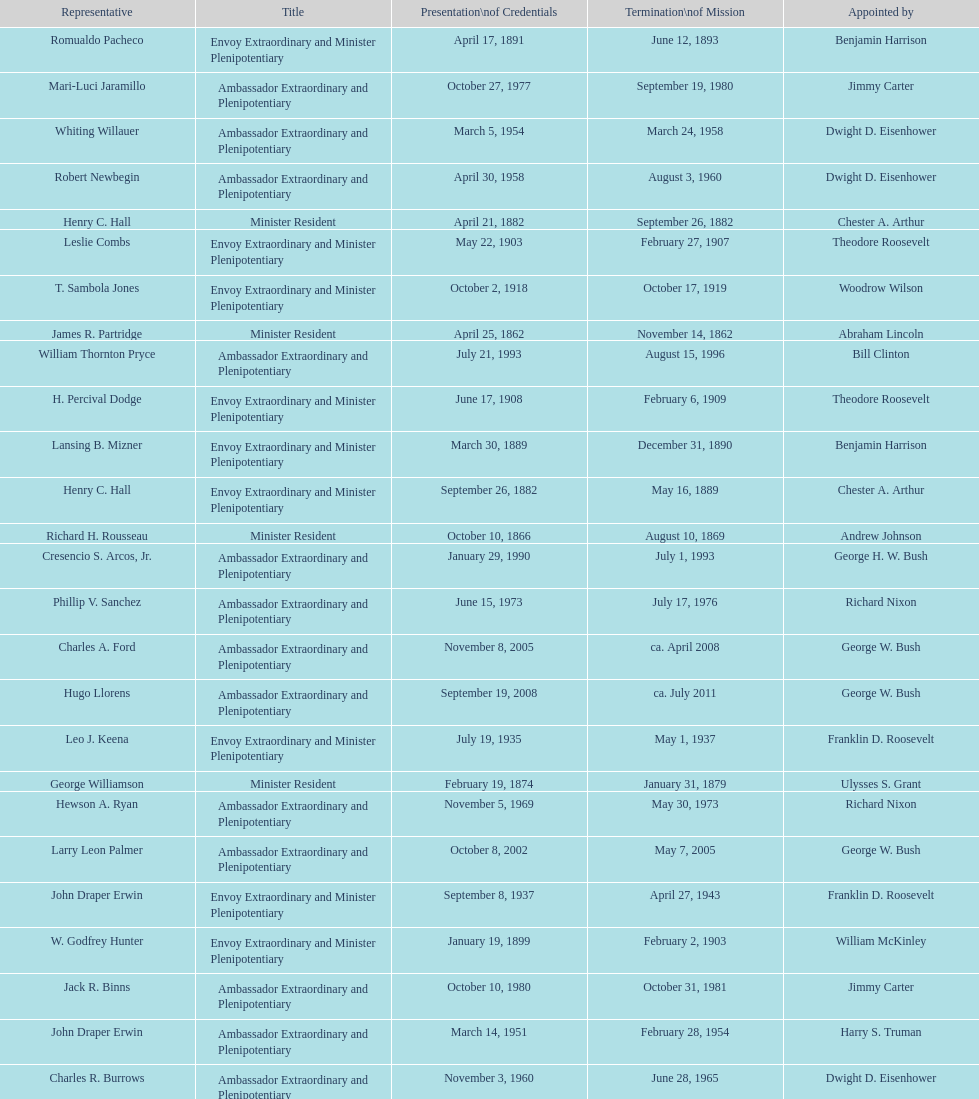Which envoy was the first appointed by woodrow wilson? John Ewing. 